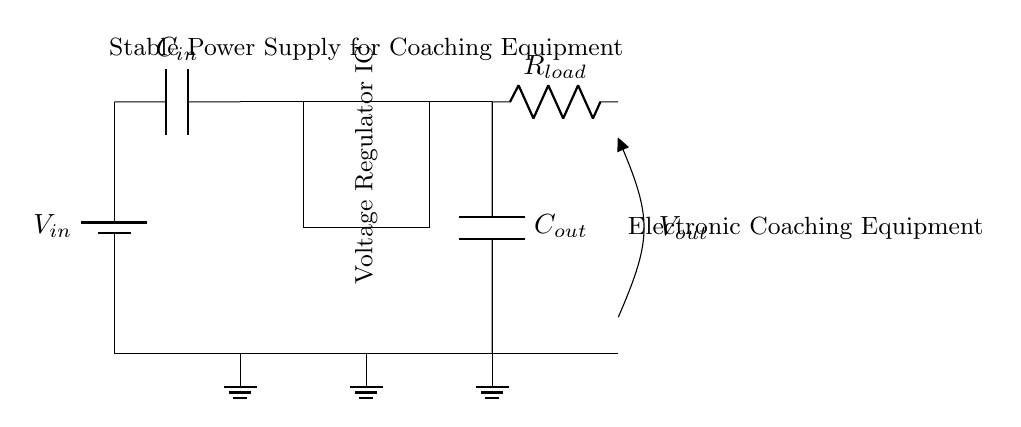What is the purpose of the voltage regulator IC? The voltage regulator IC is used to maintain a stable output voltage regardless of variations in the input voltage or load conditions, ensuring that electronic coaching equipment receives consistent power.
Answer: Maintain stable voltage What type of components are connected in parallel to the load? The output capacitor and the load resistor are connected in parallel, which means they share the same voltage across their terminals while allowing for current division.
Answer: Capacitor and resistor What does the symbol at the top left represent? The symbol at the top left is a battery, which indicates a DC voltage source supplying power to the circuit. This is essential for the operation of the voltage regulator.
Answer: Voltage source How many capacitors are in the circuit? There are two capacitors: one is the input capacitor and the other is the output capacitor, both serving critical roles in filtering and stability.
Answer: Two What is the role of the load resistor? The load resistor represents the electronic coaching equipment that consumes power from the regulated output, providing a specific load for the voltage regulator to manage.
Answer: Power consumption What happens if the input voltage increases significantly? If the input voltage increases significantly, the voltage regulator IC will adjust the output to maintain a steady voltage, protecting the connected equipment from potential damage due to over-voltage conditions.
Answer: Regulation of output What is the total ground connection in the circuit? The circuit has multiple ground connections, providing a common reference point for all voltage levels in the circuit and completing the electrical circuit for proper operation.
Answer: Multiple grounds 